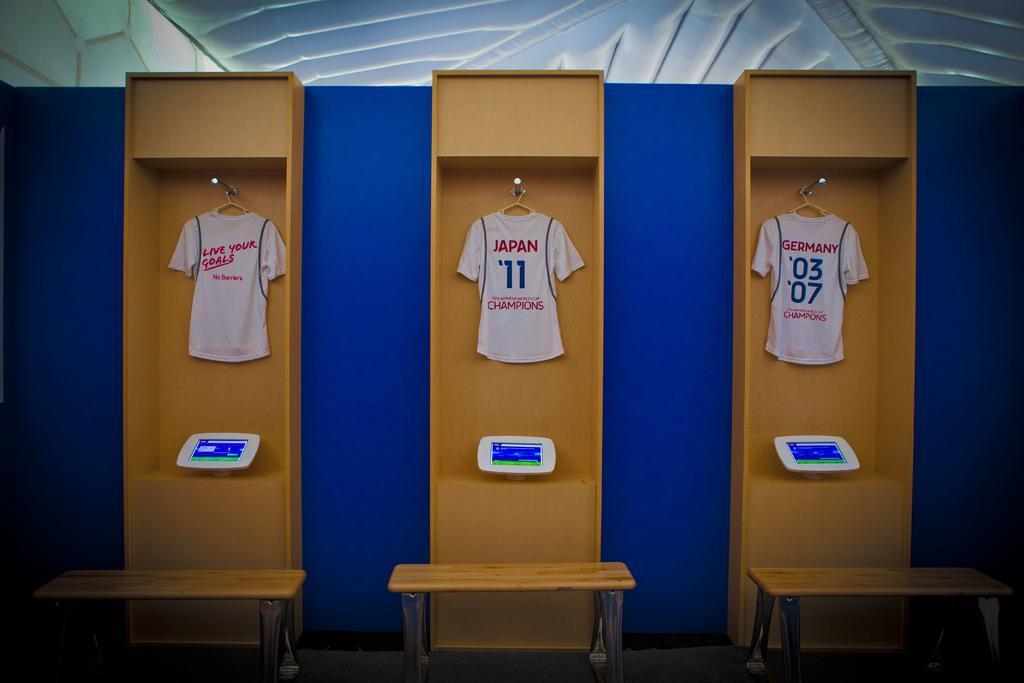In one or two sentences, can you explain what this image depicts? We can see furniture attached with screens and t shirts are hanging on hangers,in front of these furniture there are tables. On the background we can see wall. 